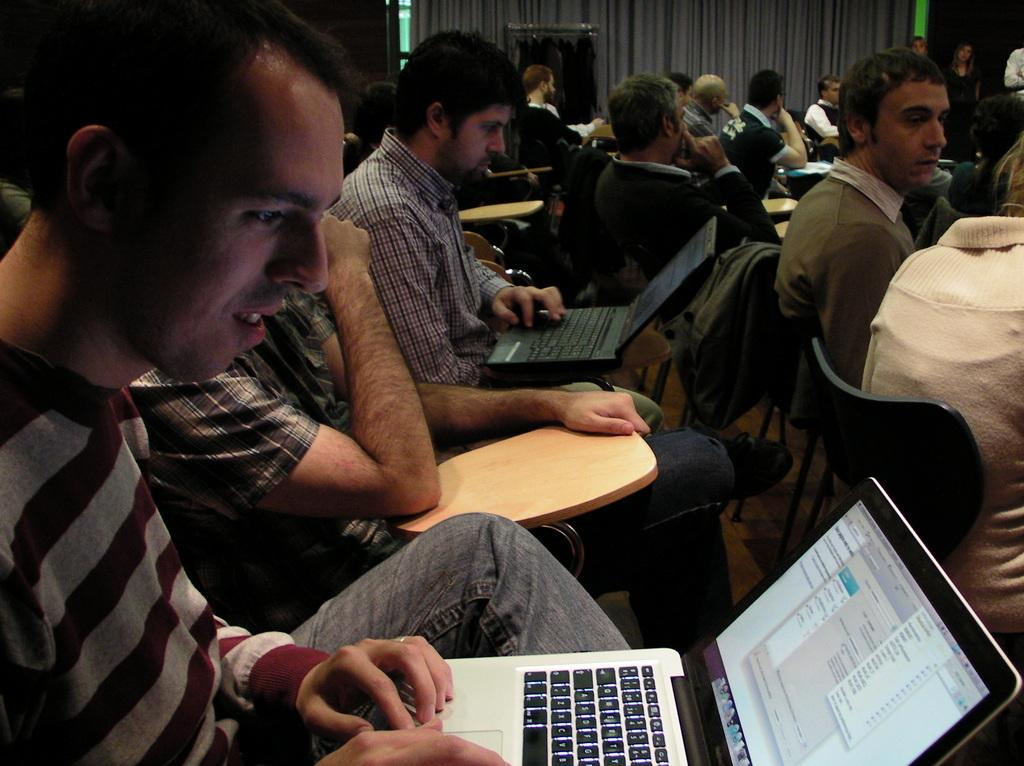What is happening in the image? There is a group of people in the image. What are the people doing in the image? The people are sitting on chairs. Can you describe any specific activities the people are engaged in? Two persons are looking into laptops. What can be seen in the background of the image? There are curtains in the background of the image. What type of steel is being polished by the people in the image? There is no steel or polishing activity present in the image. 